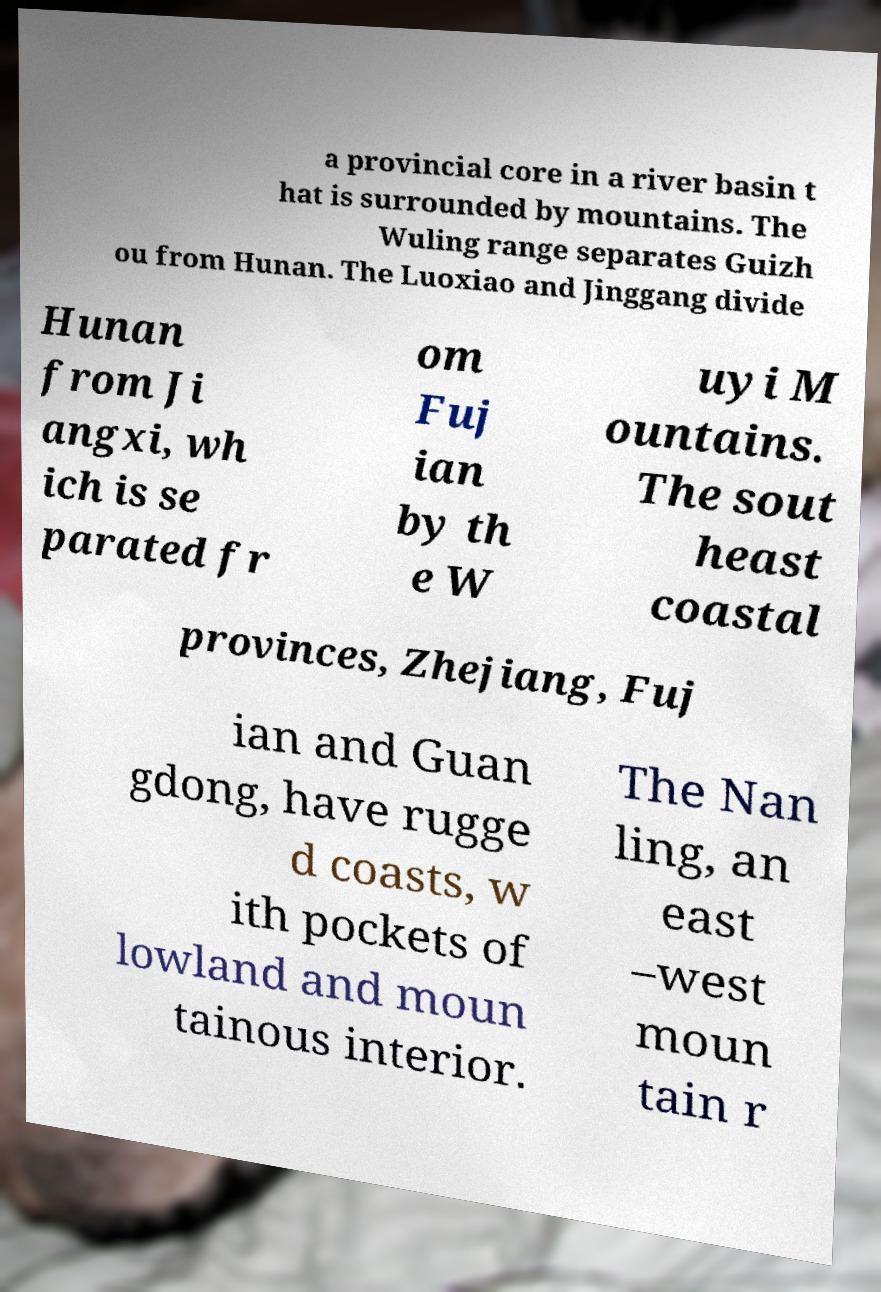For documentation purposes, I need the text within this image transcribed. Could you provide that? a provincial core in a river basin t hat is surrounded by mountains. The Wuling range separates Guizh ou from Hunan. The Luoxiao and Jinggang divide Hunan from Ji angxi, wh ich is se parated fr om Fuj ian by th e W uyi M ountains. The sout heast coastal provinces, Zhejiang, Fuj ian and Guan gdong, have rugge d coasts, w ith pockets of lowland and moun tainous interior. The Nan ling, an east –west moun tain r 